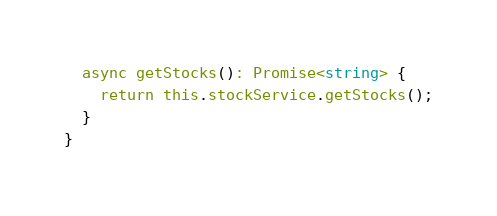Convert code to text. <code><loc_0><loc_0><loc_500><loc_500><_TypeScript_>  async getStocks(): Promise<string> {
    return this.stockService.getStocks();
  }
}
</code> 